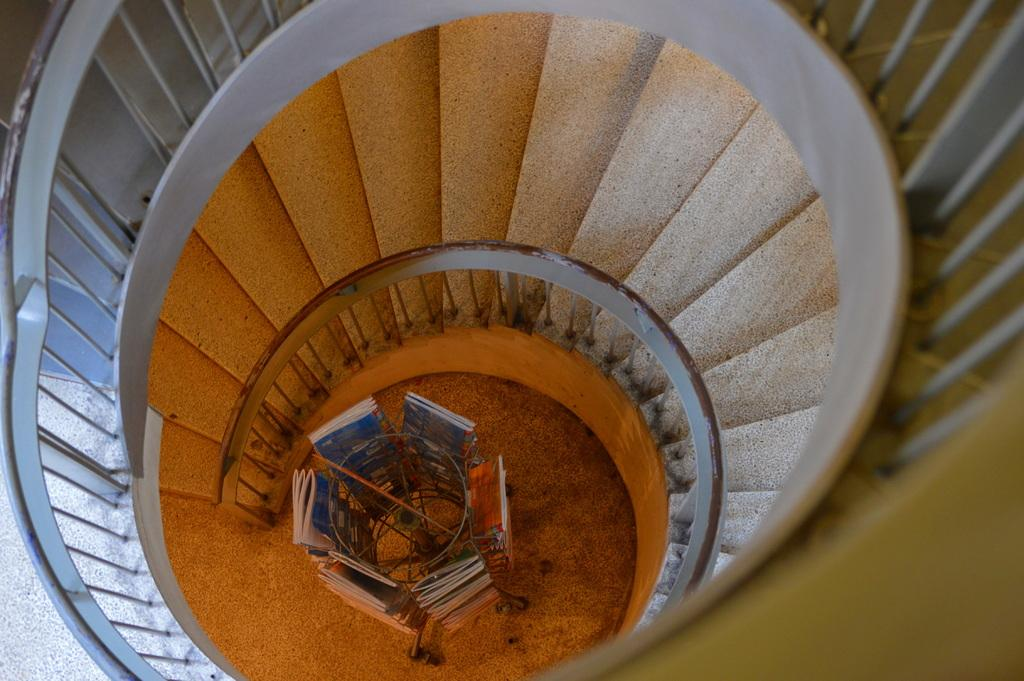What is the perspective of the image? The image is taken from the top of the steps. What can be seen in the image from this perspective? There are steps visible in the image. Is there any safety feature in the image? Yes, there is a railing in the image. What items are on the ground in the image? There are books in a book stand on the ground. Where is the kettle placed in the image? There is no kettle present in the image. Can you see a car in the image? No, there is no car visible in the image. 